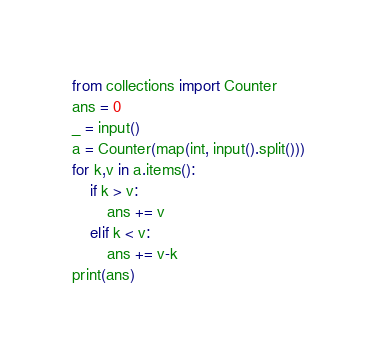Convert code to text. <code><loc_0><loc_0><loc_500><loc_500><_Python_>from collections import Counter
ans = 0
_ = input()
a = Counter(map(int, input().split()))
for k,v in a.items():
    if k > v:
        ans += v
    elif k < v:
        ans += v-k
print(ans)</code> 